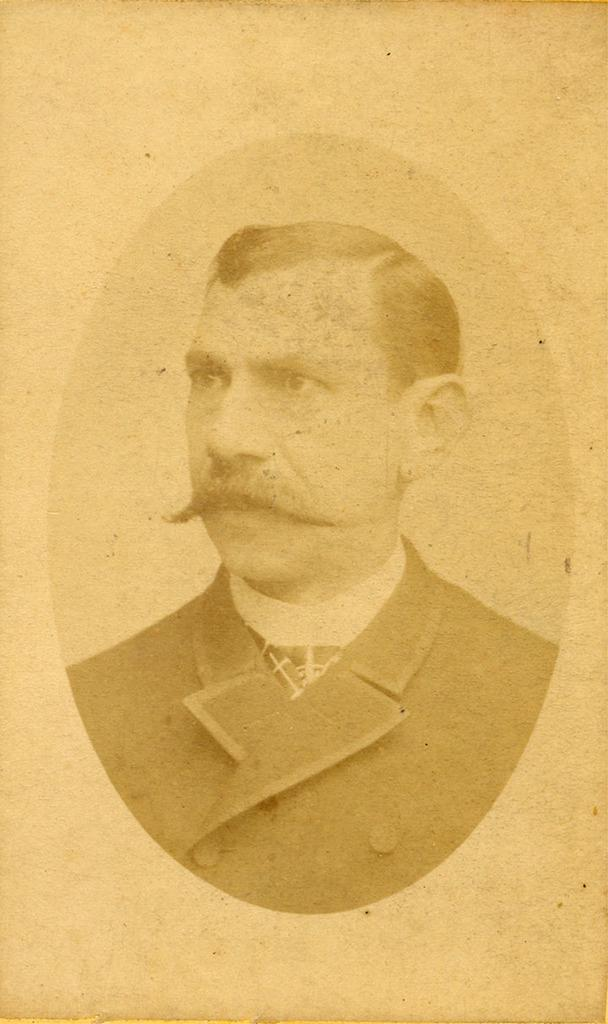What is the main subject of the image? There is a picture of a person in the image. What type of breakfast is the person eating in the image? There is no breakfast present in the image, as it only features a picture of a person. 